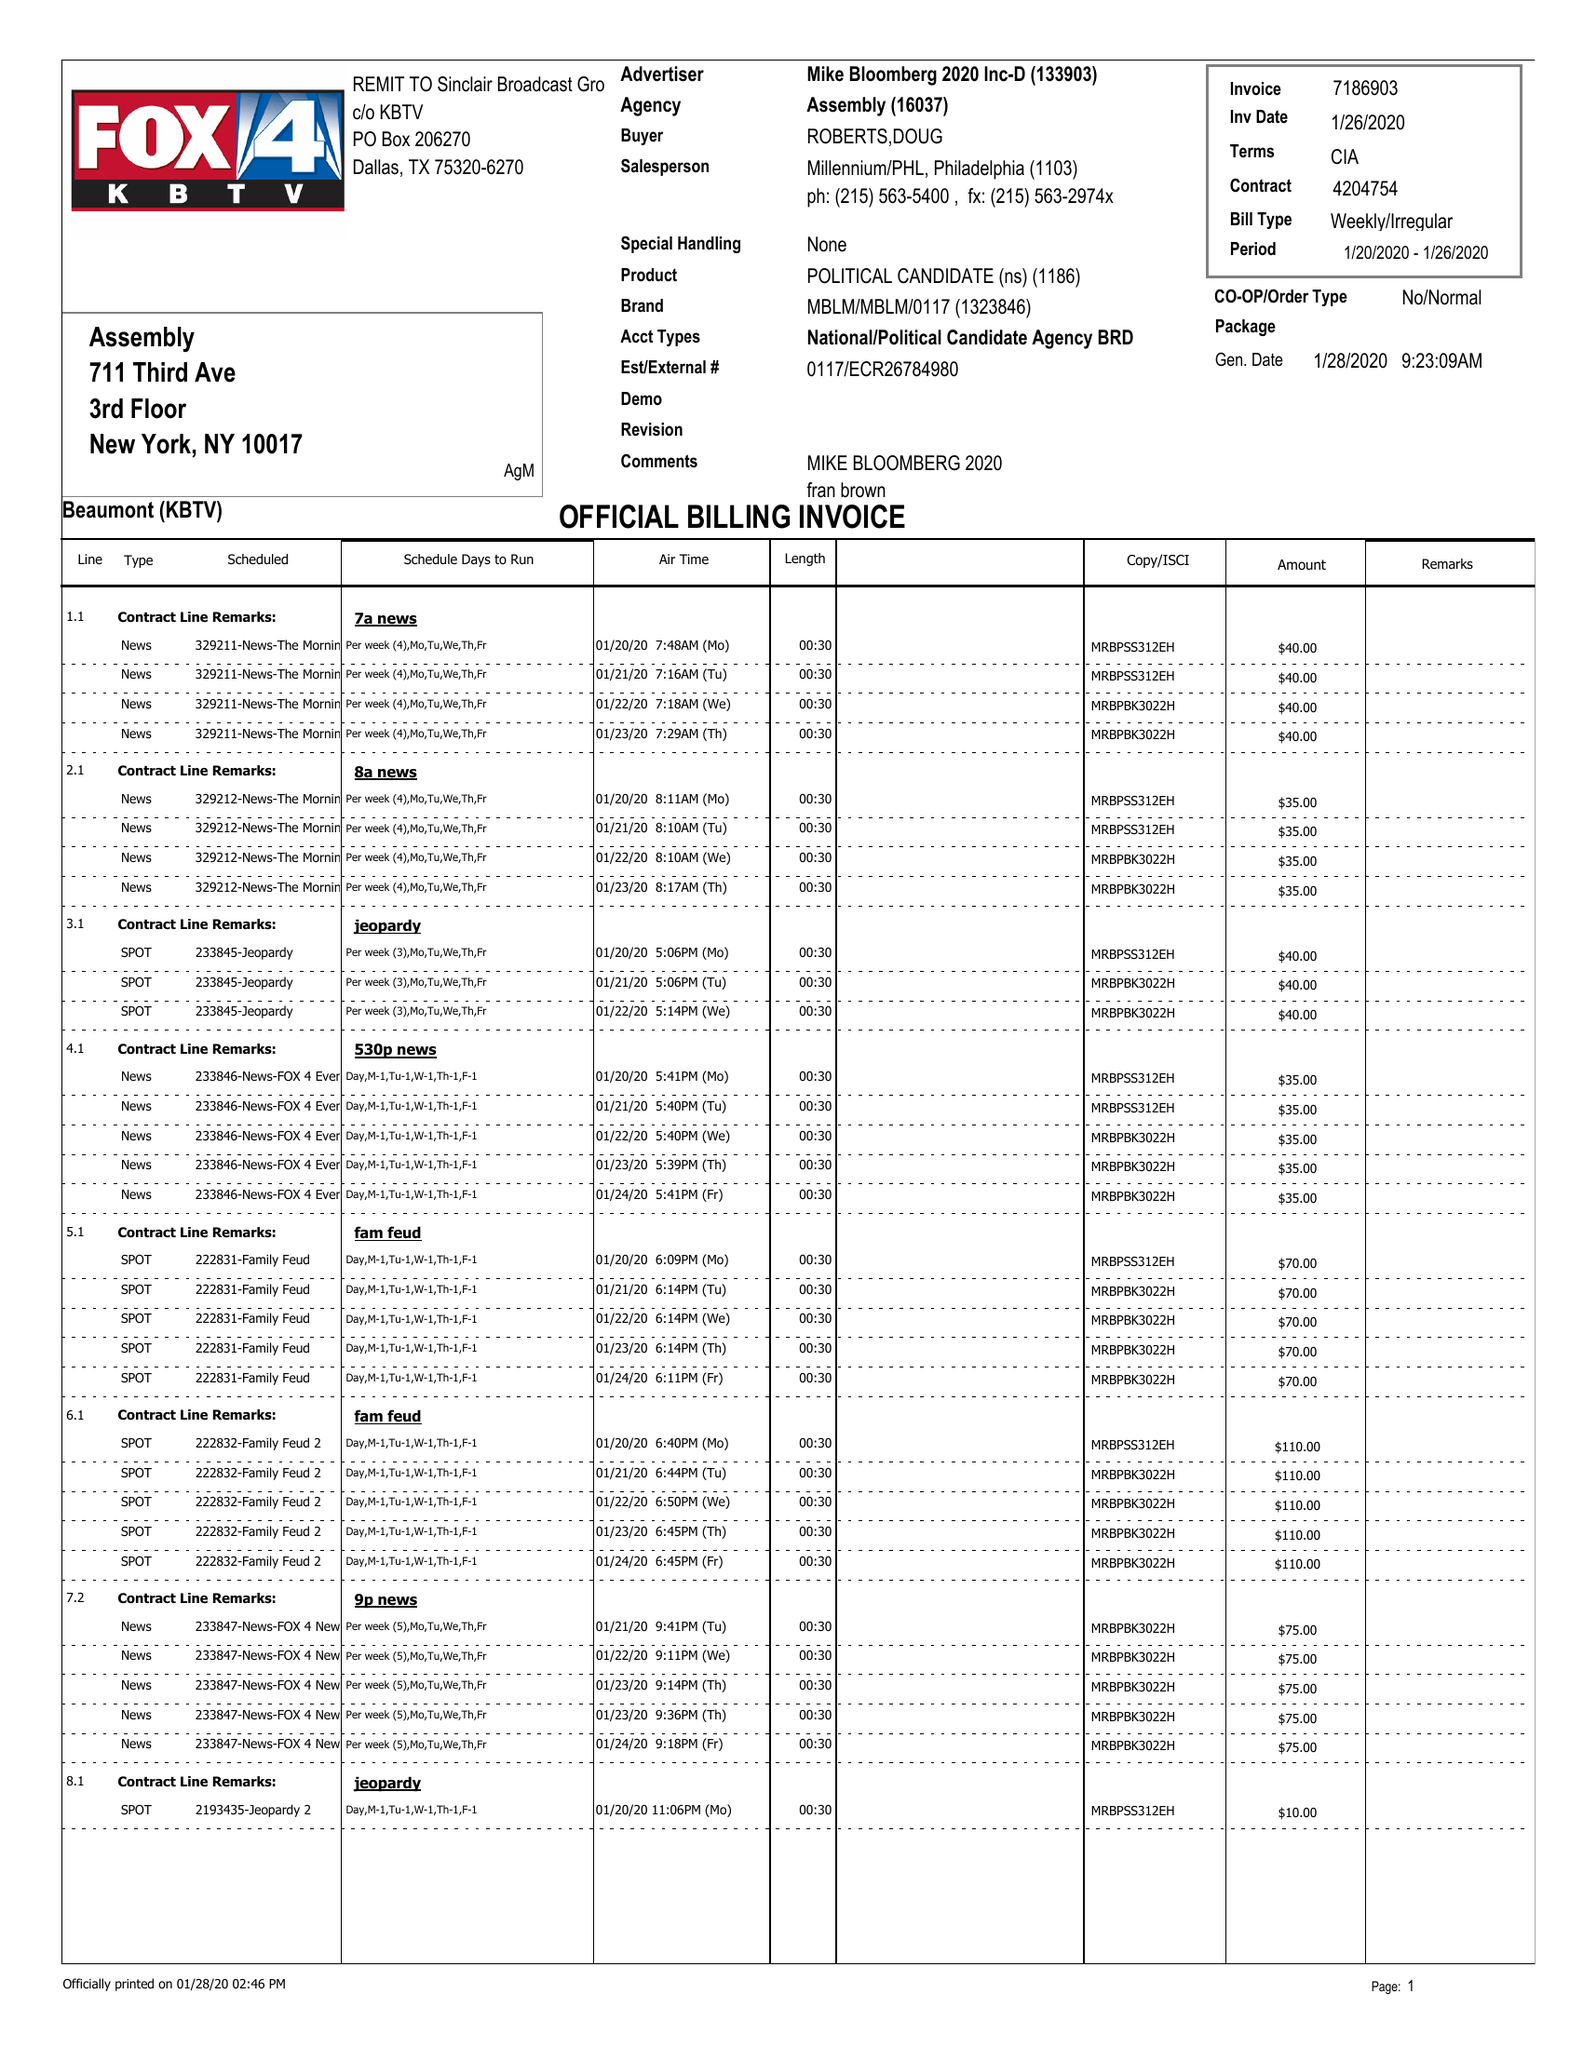What is the value for the gross_amount?
Answer the question using a single word or phrase. 2095.00 